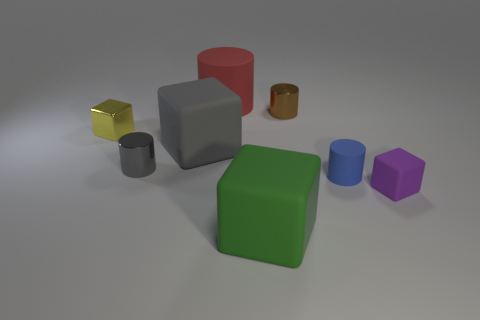Add 1 small yellow metal cylinders. How many objects exist? 9 Add 1 large red rubber things. How many large red rubber things exist? 2 Subtract 0 blue spheres. How many objects are left? 8 Subtract all tiny metal things. Subtract all gray shiny cylinders. How many objects are left? 4 Add 4 metallic blocks. How many metallic blocks are left? 5 